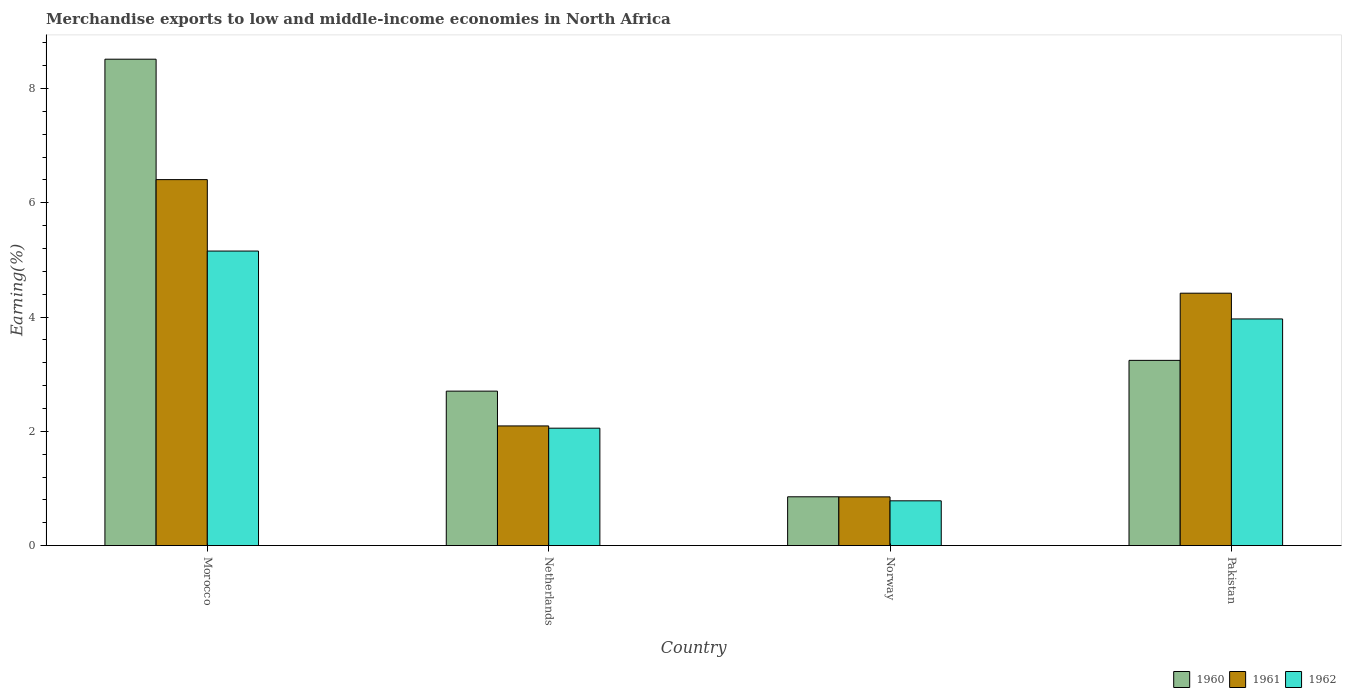How many different coloured bars are there?
Offer a very short reply. 3. Are the number of bars per tick equal to the number of legend labels?
Provide a succinct answer. Yes. Are the number of bars on each tick of the X-axis equal?
Offer a terse response. Yes. In how many cases, is the number of bars for a given country not equal to the number of legend labels?
Ensure brevity in your answer.  0. What is the percentage of amount earned from merchandise exports in 1962 in Morocco?
Your answer should be very brief. 5.15. Across all countries, what is the maximum percentage of amount earned from merchandise exports in 1961?
Offer a very short reply. 6.41. Across all countries, what is the minimum percentage of amount earned from merchandise exports in 1962?
Ensure brevity in your answer.  0.78. In which country was the percentage of amount earned from merchandise exports in 1961 maximum?
Offer a very short reply. Morocco. What is the total percentage of amount earned from merchandise exports in 1960 in the graph?
Your response must be concise. 15.31. What is the difference between the percentage of amount earned from merchandise exports in 1960 in Netherlands and that in Norway?
Ensure brevity in your answer.  1.85. What is the difference between the percentage of amount earned from merchandise exports in 1962 in Netherlands and the percentage of amount earned from merchandise exports in 1960 in Pakistan?
Give a very brief answer. -1.19. What is the average percentage of amount earned from merchandise exports in 1961 per country?
Keep it short and to the point. 3.44. What is the difference between the percentage of amount earned from merchandise exports of/in 1962 and percentage of amount earned from merchandise exports of/in 1960 in Norway?
Make the answer very short. -0.07. In how many countries, is the percentage of amount earned from merchandise exports in 1960 greater than 1.2000000000000002 %?
Your answer should be compact. 3. What is the ratio of the percentage of amount earned from merchandise exports in 1962 in Morocco to that in Netherlands?
Offer a terse response. 2.51. Is the difference between the percentage of amount earned from merchandise exports in 1962 in Morocco and Pakistan greater than the difference between the percentage of amount earned from merchandise exports in 1960 in Morocco and Pakistan?
Make the answer very short. No. What is the difference between the highest and the second highest percentage of amount earned from merchandise exports in 1961?
Make the answer very short. -2.32. What is the difference between the highest and the lowest percentage of amount earned from merchandise exports in 1962?
Keep it short and to the point. 4.37. In how many countries, is the percentage of amount earned from merchandise exports in 1962 greater than the average percentage of amount earned from merchandise exports in 1962 taken over all countries?
Provide a succinct answer. 2. What does the 1st bar from the right in Morocco represents?
Provide a short and direct response. 1962. Are all the bars in the graph horizontal?
Provide a succinct answer. No. Are the values on the major ticks of Y-axis written in scientific E-notation?
Offer a very short reply. No. Does the graph contain any zero values?
Provide a short and direct response. No. What is the title of the graph?
Make the answer very short. Merchandise exports to low and middle-income economies in North Africa. Does "2012" appear as one of the legend labels in the graph?
Your answer should be compact. No. What is the label or title of the X-axis?
Your response must be concise. Country. What is the label or title of the Y-axis?
Your answer should be compact. Earning(%). What is the Earning(%) of 1960 in Morocco?
Your response must be concise. 8.51. What is the Earning(%) in 1961 in Morocco?
Ensure brevity in your answer.  6.41. What is the Earning(%) in 1962 in Morocco?
Ensure brevity in your answer.  5.15. What is the Earning(%) of 1960 in Netherlands?
Give a very brief answer. 2.7. What is the Earning(%) in 1961 in Netherlands?
Your answer should be compact. 2.09. What is the Earning(%) in 1962 in Netherlands?
Your answer should be compact. 2.05. What is the Earning(%) of 1960 in Norway?
Your response must be concise. 0.85. What is the Earning(%) of 1961 in Norway?
Provide a succinct answer. 0.85. What is the Earning(%) in 1962 in Norway?
Offer a very short reply. 0.78. What is the Earning(%) of 1960 in Pakistan?
Your response must be concise. 3.24. What is the Earning(%) of 1961 in Pakistan?
Keep it short and to the point. 4.42. What is the Earning(%) of 1962 in Pakistan?
Provide a succinct answer. 3.97. Across all countries, what is the maximum Earning(%) of 1960?
Your answer should be compact. 8.51. Across all countries, what is the maximum Earning(%) of 1961?
Your answer should be very brief. 6.41. Across all countries, what is the maximum Earning(%) of 1962?
Provide a short and direct response. 5.15. Across all countries, what is the minimum Earning(%) of 1960?
Keep it short and to the point. 0.85. Across all countries, what is the minimum Earning(%) in 1961?
Your answer should be compact. 0.85. Across all countries, what is the minimum Earning(%) of 1962?
Give a very brief answer. 0.78. What is the total Earning(%) in 1960 in the graph?
Your response must be concise. 15.31. What is the total Earning(%) of 1961 in the graph?
Provide a succinct answer. 13.77. What is the total Earning(%) of 1962 in the graph?
Offer a terse response. 11.96. What is the difference between the Earning(%) of 1960 in Morocco and that in Netherlands?
Give a very brief answer. 5.81. What is the difference between the Earning(%) in 1961 in Morocco and that in Netherlands?
Offer a terse response. 4.31. What is the difference between the Earning(%) of 1962 in Morocco and that in Netherlands?
Offer a terse response. 3.1. What is the difference between the Earning(%) of 1960 in Morocco and that in Norway?
Your answer should be compact. 7.66. What is the difference between the Earning(%) of 1961 in Morocco and that in Norway?
Offer a terse response. 5.55. What is the difference between the Earning(%) of 1962 in Morocco and that in Norway?
Your answer should be compact. 4.37. What is the difference between the Earning(%) in 1960 in Morocco and that in Pakistan?
Offer a terse response. 5.27. What is the difference between the Earning(%) in 1961 in Morocco and that in Pakistan?
Offer a terse response. 1.99. What is the difference between the Earning(%) of 1962 in Morocco and that in Pakistan?
Give a very brief answer. 1.19. What is the difference between the Earning(%) in 1960 in Netherlands and that in Norway?
Keep it short and to the point. 1.85. What is the difference between the Earning(%) of 1961 in Netherlands and that in Norway?
Your response must be concise. 1.24. What is the difference between the Earning(%) in 1962 in Netherlands and that in Norway?
Make the answer very short. 1.27. What is the difference between the Earning(%) of 1960 in Netherlands and that in Pakistan?
Your response must be concise. -0.54. What is the difference between the Earning(%) of 1961 in Netherlands and that in Pakistan?
Give a very brief answer. -2.32. What is the difference between the Earning(%) in 1962 in Netherlands and that in Pakistan?
Your response must be concise. -1.91. What is the difference between the Earning(%) in 1960 in Norway and that in Pakistan?
Provide a succinct answer. -2.39. What is the difference between the Earning(%) in 1961 in Norway and that in Pakistan?
Your answer should be very brief. -3.57. What is the difference between the Earning(%) of 1962 in Norway and that in Pakistan?
Offer a terse response. -3.18. What is the difference between the Earning(%) in 1960 in Morocco and the Earning(%) in 1961 in Netherlands?
Your answer should be compact. 6.42. What is the difference between the Earning(%) in 1960 in Morocco and the Earning(%) in 1962 in Netherlands?
Offer a very short reply. 6.46. What is the difference between the Earning(%) of 1961 in Morocco and the Earning(%) of 1962 in Netherlands?
Your answer should be compact. 4.35. What is the difference between the Earning(%) of 1960 in Morocco and the Earning(%) of 1961 in Norway?
Provide a short and direct response. 7.66. What is the difference between the Earning(%) of 1960 in Morocco and the Earning(%) of 1962 in Norway?
Give a very brief answer. 7.73. What is the difference between the Earning(%) of 1961 in Morocco and the Earning(%) of 1962 in Norway?
Offer a very short reply. 5.62. What is the difference between the Earning(%) in 1960 in Morocco and the Earning(%) in 1961 in Pakistan?
Give a very brief answer. 4.1. What is the difference between the Earning(%) in 1960 in Morocco and the Earning(%) in 1962 in Pakistan?
Provide a succinct answer. 4.55. What is the difference between the Earning(%) of 1961 in Morocco and the Earning(%) of 1962 in Pakistan?
Your answer should be compact. 2.44. What is the difference between the Earning(%) of 1960 in Netherlands and the Earning(%) of 1961 in Norway?
Provide a succinct answer. 1.85. What is the difference between the Earning(%) of 1960 in Netherlands and the Earning(%) of 1962 in Norway?
Provide a short and direct response. 1.92. What is the difference between the Earning(%) of 1961 in Netherlands and the Earning(%) of 1962 in Norway?
Provide a short and direct response. 1.31. What is the difference between the Earning(%) of 1960 in Netherlands and the Earning(%) of 1961 in Pakistan?
Ensure brevity in your answer.  -1.71. What is the difference between the Earning(%) of 1960 in Netherlands and the Earning(%) of 1962 in Pakistan?
Provide a short and direct response. -1.26. What is the difference between the Earning(%) of 1961 in Netherlands and the Earning(%) of 1962 in Pakistan?
Make the answer very short. -1.87. What is the difference between the Earning(%) of 1960 in Norway and the Earning(%) of 1961 in Pakistan?
Ensure brevity in your answer.  -3.56. What is the difference between the Earning(%) of 1960 in Norway and the Earning(%) of 1962 in Pakistan?
Offer a very short reply. -3.11. What is the difference between the Earning(%) in 1961 in Norway and the Earning(%) in 1962 in Pakistan?
Your answer should be very brief. -3.11. What is the average Earning(%) in 1960 per country?
Your answer should be very brief. 3.83. What is the average Earning(%) in 1961 per country?
Provide a succinct answer. 3.44. What is the average Earning(%) in 1962 per country?
Ensure brevity in your answer.  2.99. What is the difference between the Earning(%) of 1960 and Earning(%) of 1961 in Morocco?
Your answer should be very brief. 2.11. What is the difference between the Earning(%) in 1960 and Earning(%) in 1962 in Morocco?
Offer a very short reply. 3.36. What is the difference between the Earning(%) in 1961 and Earning(%) in 1962 in Morocco?
Ensure brevity in your answer.  1.25. What is the difference between the Earning(%) in 1960 and Earning(%) in 1961 in Netherlands?
Your response must be concise. 0.61. What is the difference between the Earning(%) in 1960 and Earning(%) in 1962 in Netherlands?
Your answer should be very brief. 0.65. What is the difference between the Earning(%) in 1961 and Earning(%) in 1962 in Netherlands?
Give a very brief answer. 0.04. What is the difference between the Earning(%) of 1960 and Earning(%) of 1961 in Norway?
Offer a very short reply. 0. What is the difference between the Earning(%) of 1960 and Earning(%) of 1962 in Norway?
Give a very brief answer. 0.07. What is the difference between the Earning(%) of 1961 and Earning(%) of 1962 in Norway?
Keep it short and to the point. 0.07. What is the difference between the Earning(%) in 1960 and Earning(%) in 1961 in Pakistan?
Keep it short and to the point. -1.18. What is the difference between the Earning(%) of 1960 and Earning(%) of 1962 in Pakistan?
Your answer should be compact. -0.73. What is the difference between the Earning(%) in 1961 and Earning(%) in 1962 in Pakistan?
Offer a very short reply. 0.45. What is the ratio of the Earning(%) of 1960 in Morocco to that in Netherlands?
Make the answer very short. 3.15. What is the ratio of the Earning(%) of 1961 in Morocco to that in Netherlands?
Ensure brevity in your answer.  3.06. What is the ratio of the Earning(%) in 1962 in Morocco to that in Netherlands?
Provide a succinct answer. 2.51. What is the ratio of the Earning(%) in 1960 in Morocco to that in Norway?
Keep it short and to the point. 9.97. What is the ratio of the Earning(%) in 1961 in Morocco to that in Norway?
Offer a terse response. 7.52. What is the ratio of the Earning(%) in 1962 in Morocco to that in Norway?
Ensure brevity in your answer.  6.58. What is the ratio of the Earning(%) in 1960 in Morocco to that in Pakistan?
Your answer should be very brief. 2.63. What is the ratio of the Earning(%) of 1961 in Morocco to that in Pakistan?
Your answer should be compact. 1.45. What is the ratio of the Earning(%) in 1962 in Morocco to that in Pakistan?
Keep it short and to the point. 1.3. What is the ratio of the Earning(%) of 1960 in Netherlands to that in Norway?
Make the answer very short. 3.17. What is the ratio of the Earning(%) in 1961 in Netherlands to that in Norway?
Keep it short and to the point. 2.46. What is the ratio of the Earning(%) of 1962 in Netherlands to that in Norway?
Your response must be concise. 2.62. What is the ratio of the Earning(%) in 1960 in Netherlands to that in Pakistan?
Make the answer very short. 0.83. What is the ratio of the Earning(%) of 1961 in Netherlands to that in Pakistan?
Offer a very short reply. 0.47. What is the ratio of the Earning(%) in 1962 in Netherlands to that in Pakistan?
Provide a succinct answer. 0.52. What is the ratio of the Earning(%) in 1960 in Norway to that in Pakistan?
Your response must be concise. 0.26. What is the ratio of the Earning(%) in 1961 in Norway to that in Pakistan?
Provide a succinct answer. 0.19. What is the ratio of the Earning(%) in 1962 in Norway to that in Pakistan?
Provide a succinct answer. 0.2. What is the difference between the highest and the second highest Earning(%) of 1960?
Make the answer very short. 5.27. What is the difference between the highest and the second highest Earning(%) of 1961?
Your answer should be compact. 1.99. What is the difference between the highest and the second highest Earning(%) of 1962?
Provide a short and direct response. 1.19. What is the difference between the highest and the lowest Earning(%) of 1960?
Ensure brevity in your answer.  7.66. What is the difference between the highest and the lowest Earning(%) in 1961?
Offer a very short reply. 5.55. What is the difference between the highest and the lowest Earning(%) in 1962?
Ensure brevity in your answer.  4.37. 